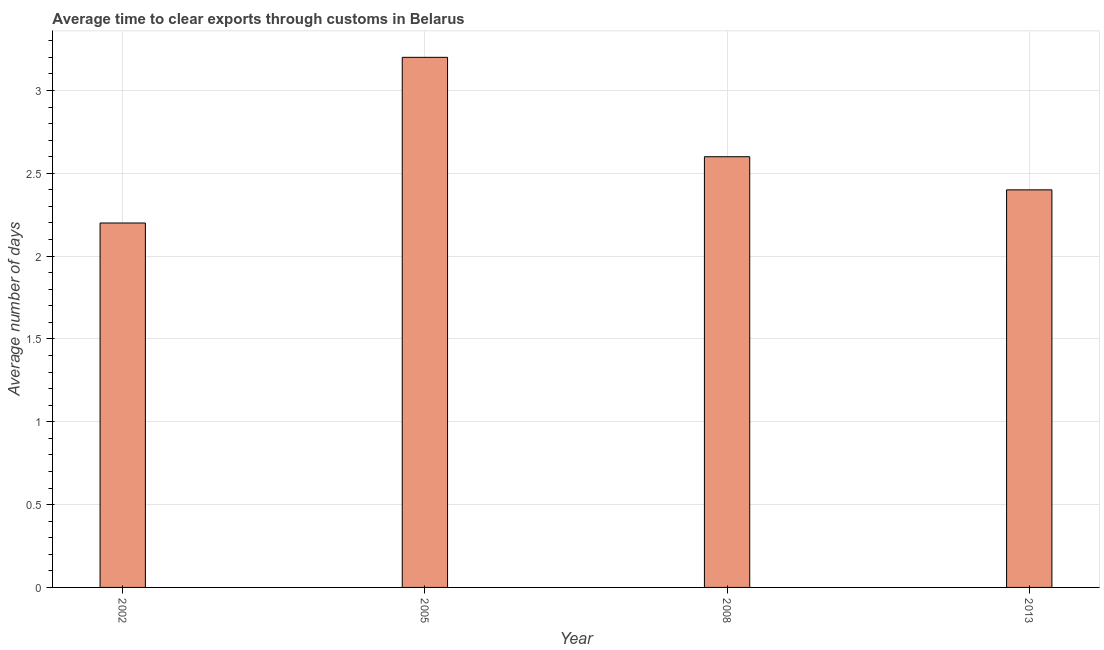Does the graph contain any zero values?
Offer a terse response. No. Does the graph contain grids?
Your response must be concise. Yes. What is the title of the graph?
Offer a terse response. Average time to clear exports through customs in Belarus. What is the label or title of the X-axis?
Provide a succinct answer. Year. What is the label or title of the Y-axis?
Your response must be concise. Average number of days. Across all years, what is the minimum time to clear exports through customs?
Provide a succinct answer. 2.2. What is the difference between the time to clear exports through customs in 2002 and 2008?
Give a very brief answer. -0.4. What is the average time to clear exports through customs per year?
Your response must be concise. 2.6. What is the ratio of the time to clear exports through customs in 2002 to that in 2013?
Offer a very short reply. 0.92. Is the time to clear exports through customs in 2002 less than that in 2005?
Offer a very short reply. Yes. Is the difference between the time to clear exports through customs in 2008 and 2013 greater than the difference between any two years?
Ensure brevity in your answer.  No. What is the difference between the highest and the second highest time to clear exports through customs?
Keep it short and to the point. 0.6. Is the sum of the time to clear exports through customs in 2002 and 2005 greater than the maximum time to clear exports through customs across all years?
Give a very brief answer. Yes. In how many years, is the time to clear exports through customs greater than the average time to clear exports through customs taken over all years?
Provide a succinct answer. 1. What is the Average number of days of 2002?
Your response must be concise. 2.2. What is the Average number of days in 2008?
Provide a short and direct response. 2.6. What is the difference between the Average number of days in 2002 and 2008?
Offer a very short reply. -0.4. What is the difference between the Average number of days in 2005 and 2013?
Give a very brief answer. 0.8. What is the ratio of the Average number of days in 2002 to that in 2005?
Make the answer very short. 0.69. What is the ratio of the Average number of days in 2002 to that in 2008?
Your answer should be compact. 0.85. What is the ratio of the Average number of days in 2002 to that in 2013?
Ensure brevity in your answer.  0.92. What is the ratio of the Average number of days in 2005 to that in 2008?
Make the answer very short. 1.23. What is the ratio of the Average number of days in 2005 to that in 2013?
Keep it short and to the point. 1.33. What is the ratio of the Average number of days in 2008 to that in 2013?
Provide a short and direct response. 1.08. 